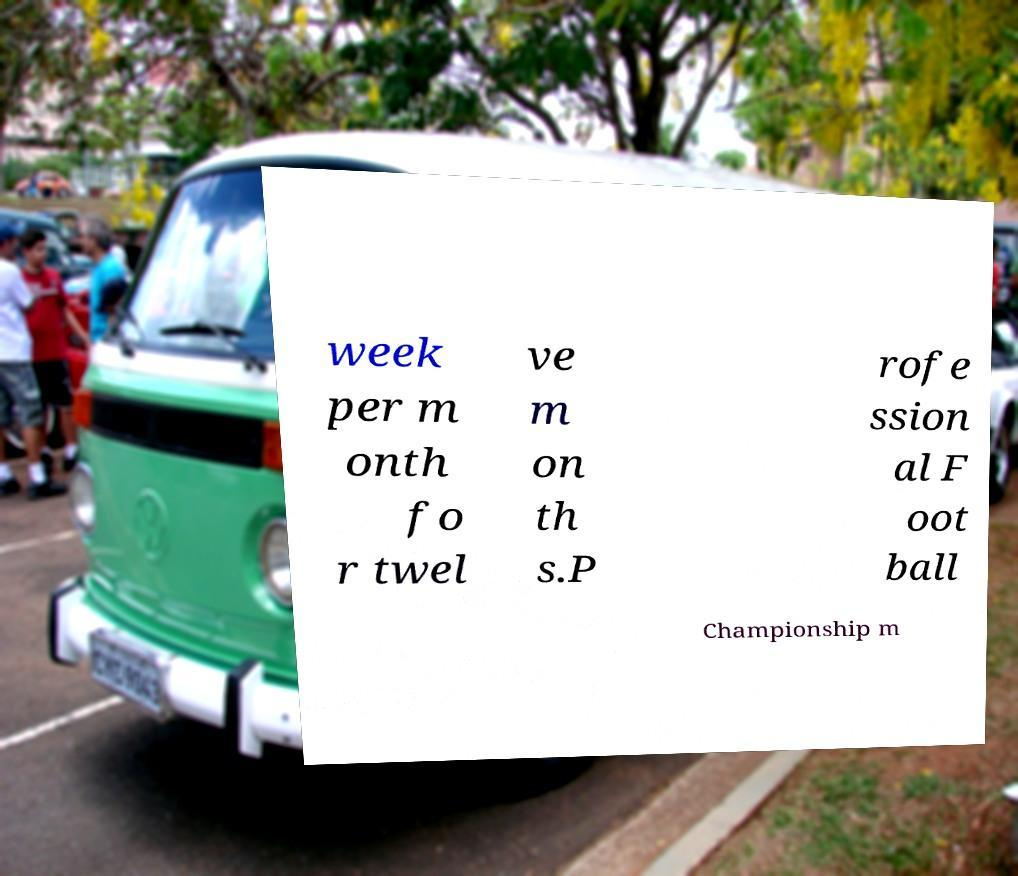I need the written content from this picture converted into text. Can you do that? week per m onth fo r twel ve m on th s.P rofe ssion al F oot ball Championship m 